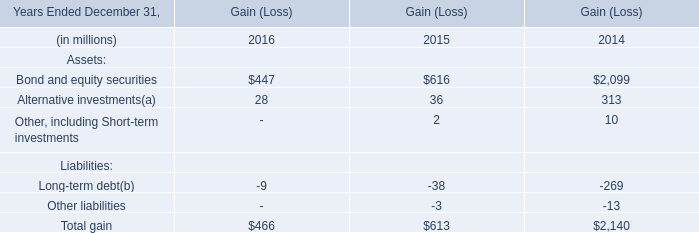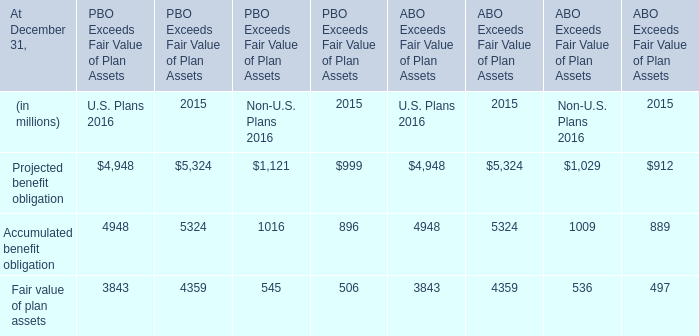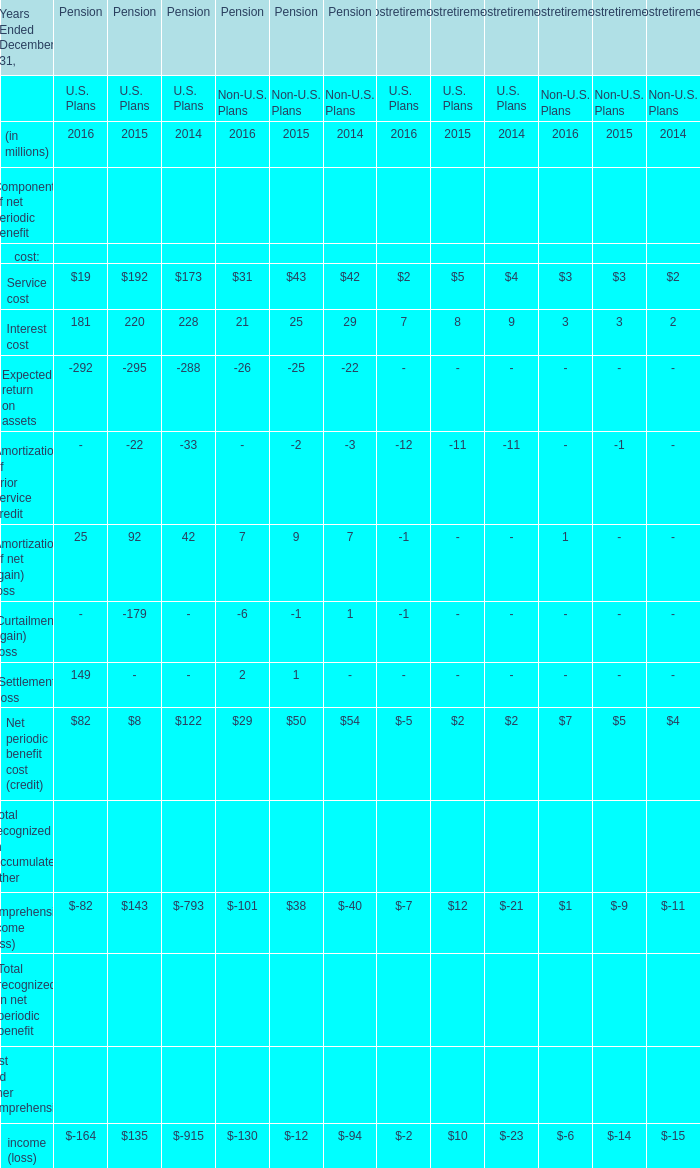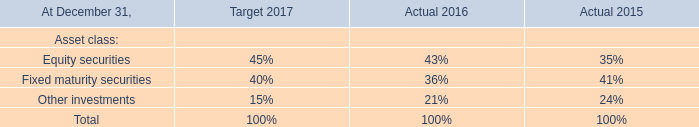What's the difference of Service cost between 2015 and 2016? (in million) 
Computations: ((((19 + 31) + 2) + 3) - (((192 + 43) + 5) + 3))
Answer: -188.0. 